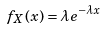<formula> <loc_0><loc_0><loc_500><loc_500>f _ { X } ( x ) = \lambda e ^ { - \lambda x }</formula> 